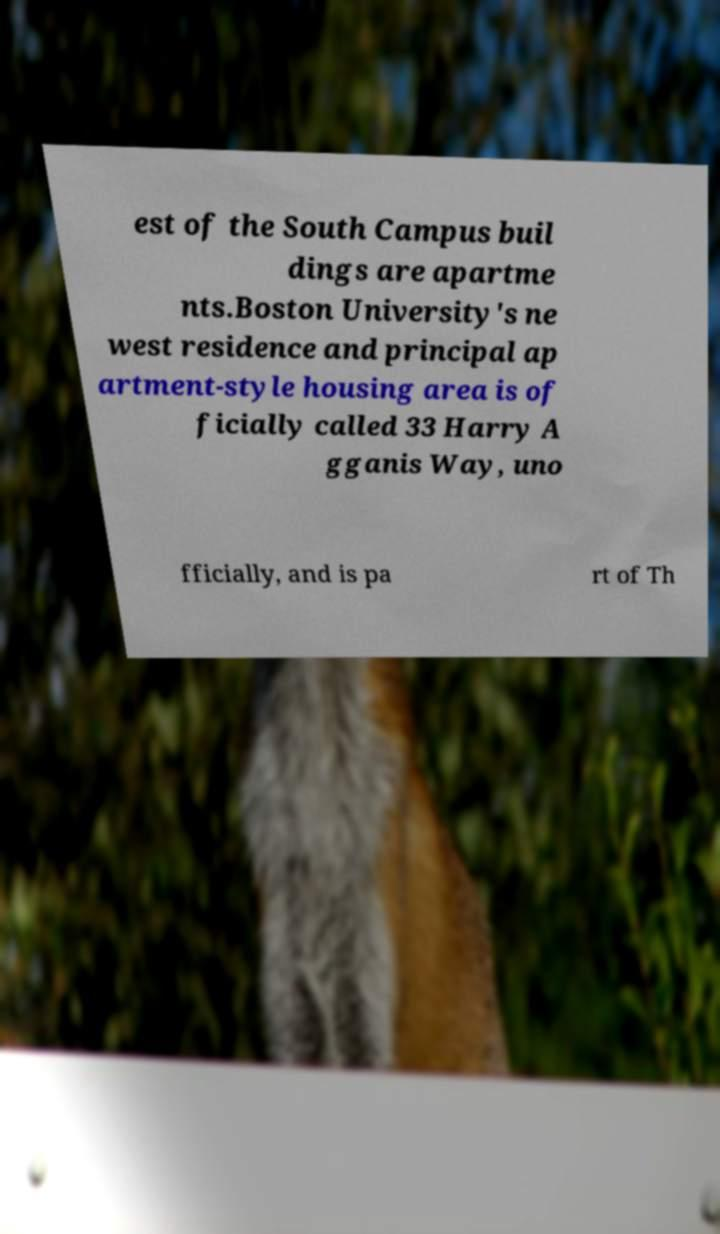Please read and relay the text visible in this image. What does it say? est of the South Campus buil dings are apartme nts.Boston University's ne west residence and principal ap artment-style housing area is of ficially called 33 Harry A gganis Way, uno fficially, and is pa rt of Th 